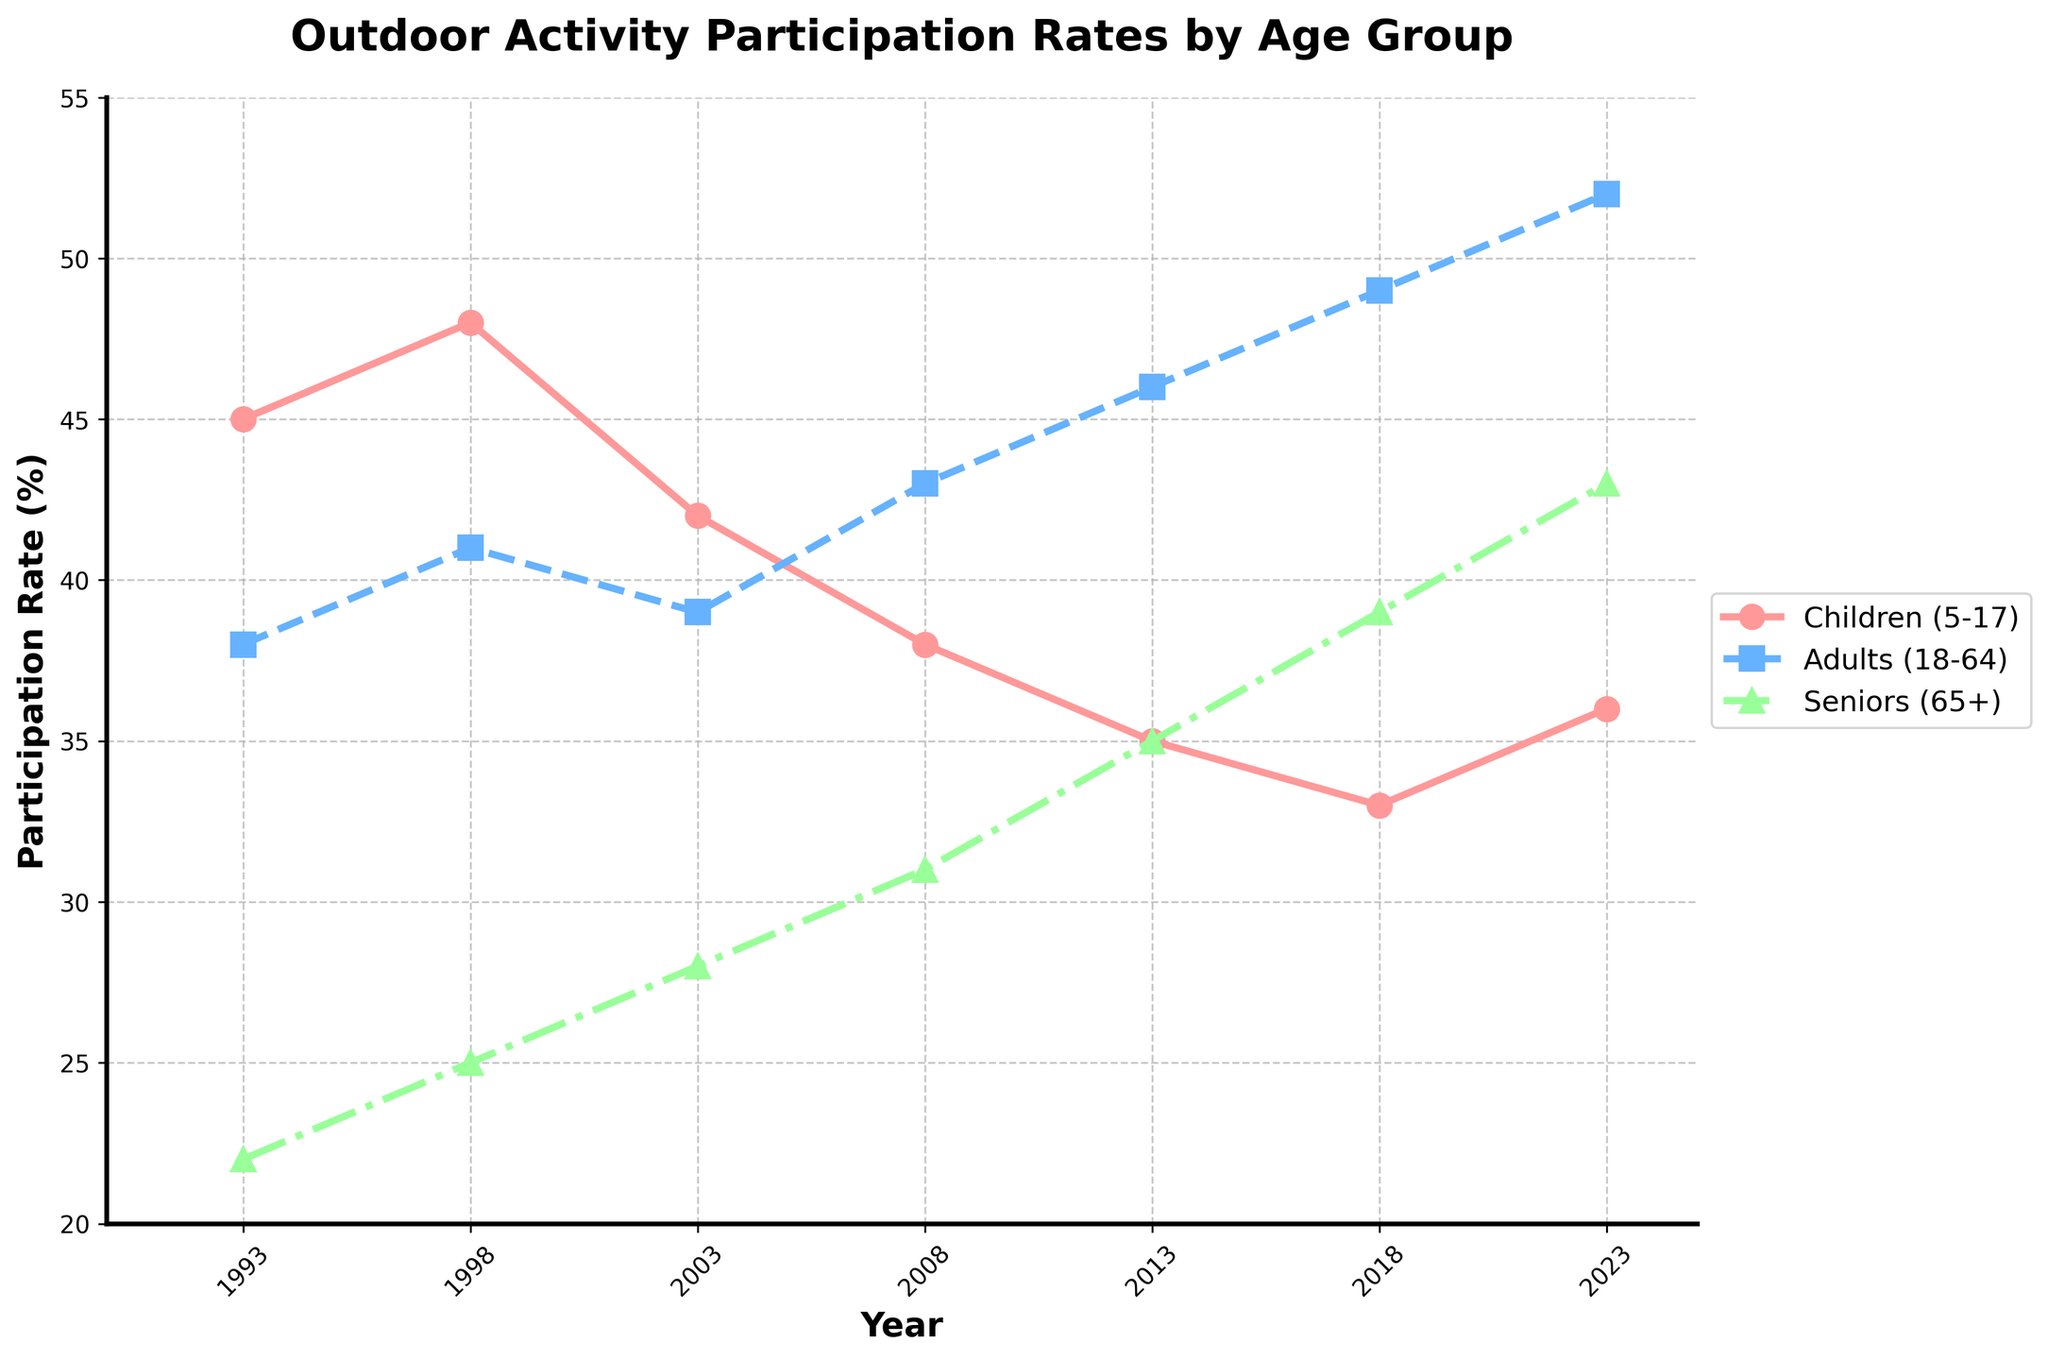What is the participation rate for children in 2023? The line labeled "Children (5-17)" shows the participation rate. By following the line to the year 2023 on the x-axis, the participation rate is 36%.
Answer: 36% Between 1993 and 2023, which age group shows the greatest increase in participation rate? To find the greatest increase, calculate the difference between the participation rates in 2023 and 1993 for each group: Children (36-45=-9), Adults (52-38=14), Seniors (43-22=21). The seniors have the greatest increase.
Answer: Seniors How did the participation rate of adults change from 1993 to 2013? Look at the participation rate for adults in 1993 (38%) and 2013 (46%). The change is 46% - 38% = 8%.
Answer: Increased by 8% Given all groups, who experienced the lowest participation rate in 1993? Comparing the participation rates in 1993 for each group: Children (45%), Adults (38%), Seniors (22%). Seniors have the lowest rate.
Answer: Seniors What is the average participation rate for seniors across all years? Sum the participation rates for seniors for all years: (22+25+28+31+35+39+43) = 223. There are 7 years, so the average is 223 / 7 ≈ 31.86%.
Answer: 31.86% Which age group had the highest participation rate in 2008? By comparing the rates in 2008: Children (38%), Adults (43%), Seniors (31%). Adults had the highest.
Answer: Adults Between which consecutive years did the participation rate for children decrease the most? Calculate the decrease between the consecutive years: 1998-2003 (48-42=6), 2003-2008 (42-38=4), 2008-2013 (38-35=3), 2013-2018 (35-33=2), 2018-2023 (33-36=-3). The greatest decrease occurred between 1998 and 2003.
Answer: 1998 to 2003 Which group shows a continuous increase in participation rate from 1993 to 2023? Observing the trend lines, only the line for seniors shows a continuous increase without any drops from 1993 to 2023.
Answer: Seniors By how much did the children's participation rate drop from its highest point in the data? The highest participation rate for children was 48% in 1998 and it dropped to 33% in 2018. The difference is 48% - 33% = 15%.
Answer: 15% 